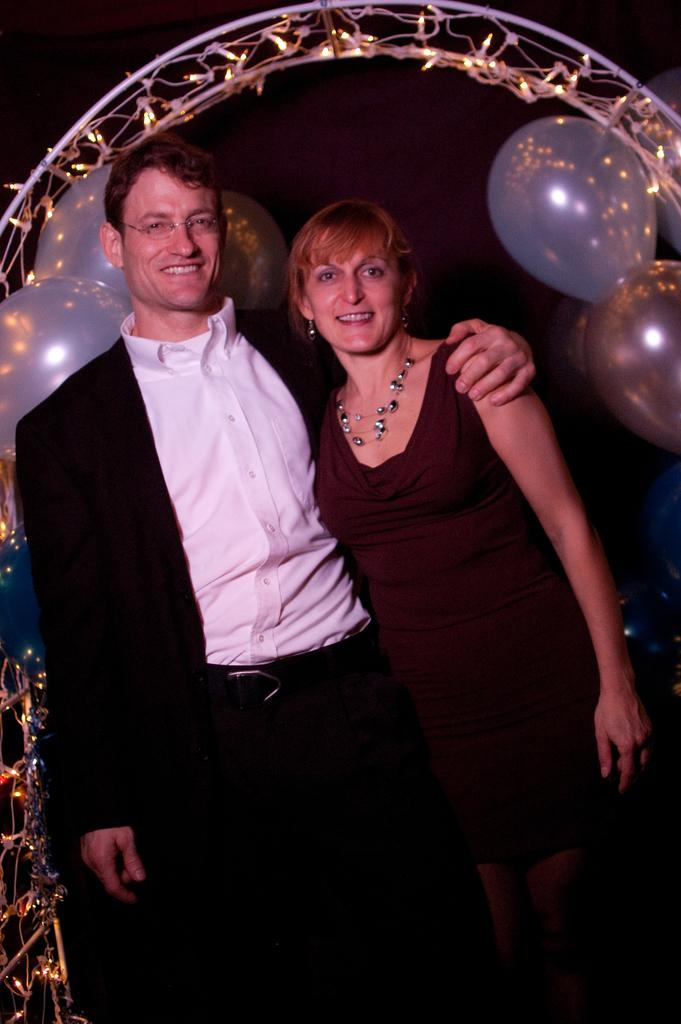How many people are present in the image? There are two people, a man and a woman, present in the image. What are the man and woman doing in the image? The man and woman are standing. What can be seen in the background of the image? There is a metal frame in the background of the image, with lights and balloons on it. What type of apple is being advertised on the metal frame in the image? There is no apple or advertisement present in the image; it only features a metal frame with lights and balloons. 